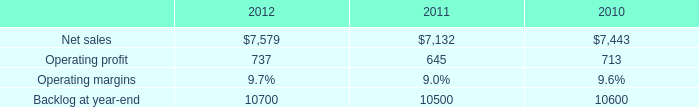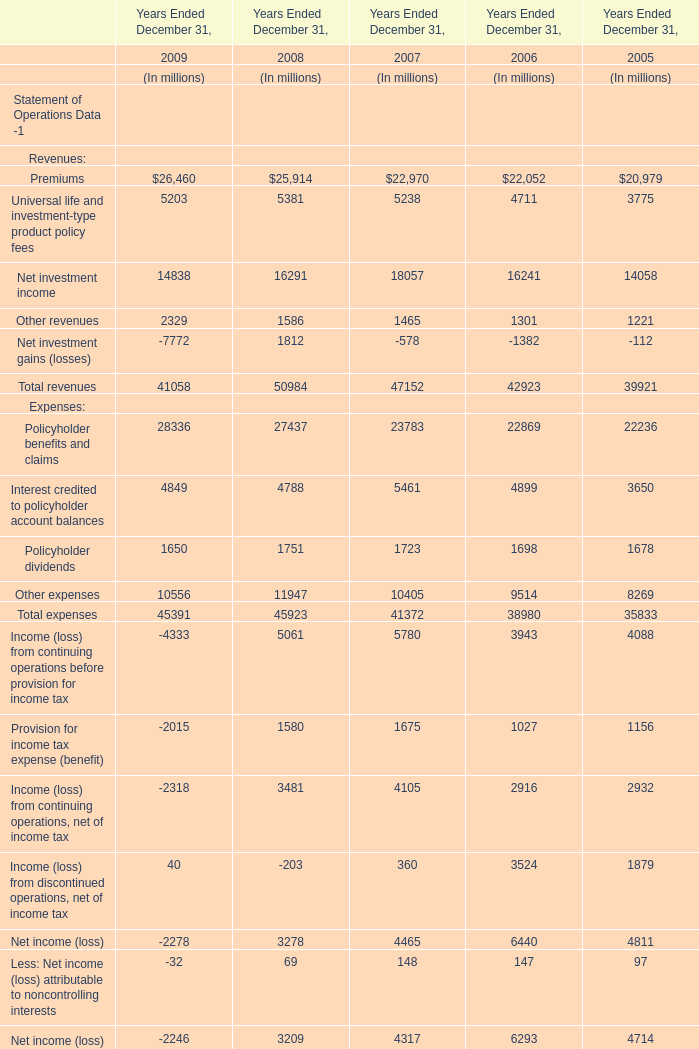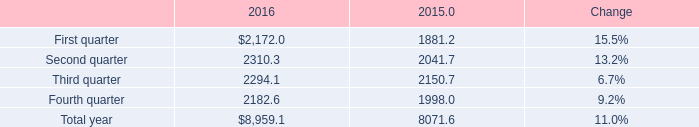What is the total amount of Net sales of 2011, and Third quarter of 2016 ? 
Computations: (7132.0 + 2294.1)
Answer: 9426.1. 